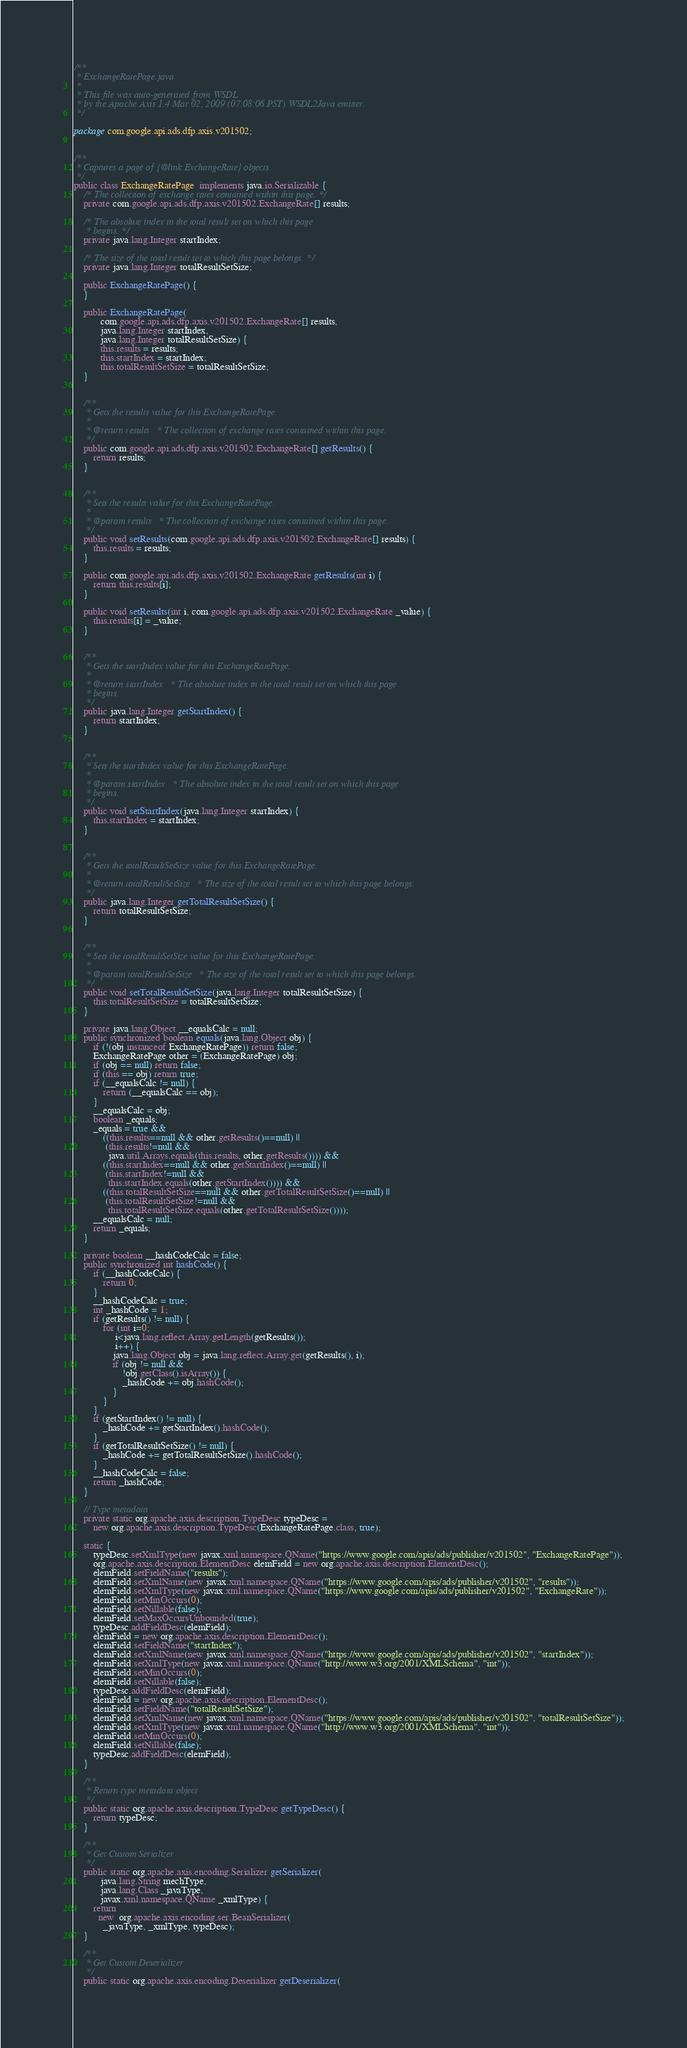Convert code to text. <code><loc_0><loc_0><loc_500><loc_500><_Java_>/**
 * ExchangeRatePage.java
 *
 * This file was auto-generated from WSDL
 * by the Apache Axis 1.4 Mar 02, 2009 (07:08:06 PST) WSDL2Java emitter.
 */

package com.google.api.ads.dfp.axis.v201502;


/**
 * Captures a page of {@link ExchangeRate} objects.
 */
public class ExchangeRatePage  implements java.io.Serializable {
    /* The collection of exchange rates contained within this page. */
    private com.google.api.ads.dfp.axis.v201502.ExchangeRate[] results;

    /* The absolute index in the total result set on which this page
     * begins. */
    private java.lang.Integer startIndex;

    /* The size of the total result set to which this page belongs. */
    private java.lang.Integer totalResultSetSize;

    public ExchangeRatePage() {
    }

    public ExchangeRatePage(
           com.google.api.ads.dfp.axis.v201502.ExchangeRate[] results,
           java.lang.Integer startIndex,
           java.lang.Integer totalResultSetSize) {
           this.results = results;
           this.startIndex = startIndex;
           this.totalResultSetSize = totalResultSetSize;
    }


    /**
     * Gets the results value for this ExchangeRatePage.
     * 
     * @return results   * The collection of exchange rates contained within this page.
     */
    public com.google.api.ads.dfp.axis.v201502.ExchangeRate[] getResults() {
        return results;
    }


    /**
     * Sets the results value for this ExchangeRatePage.
     * 
     * @param results   * The collection of exchange rates contained within this page.
     */
    public void setResults(com.google.api.ads.dfp.axis.v201502.ExchangeRate[] results) {
        this.results = results;
    }

    public com.google.api.ads.dfp.axis.v201502.ExchangeRate getResults(int i) {
        return this.results[i];
    }

    public void setResults(int i, com.google.api.ads.dfp.axis.v201502.ExchangeRate _value) {
        this.results[i] = _value;
    }


    /**
     * Gets the startIndex value for this ExchangeRatePage.
     * 
     * @return startIndex   * The absolute index in the total result set on which this page
     * begins.
     */
    public java.lang.Integer getStartIndex() {
        return startIndex;
    }


    /**
     * Sets the startIndex value for this ExchangeRatePage.
     * 
     * @param startIndex   * The absolute index in the total result set on which this page
     * begins.
     */
    public void setStartIndex(java.lang.Integer startIndex) {
        this.startIndex = startIndex;
    }


    /**
     * Gets the totalResultSetSize value for this ExchangeRatePage.
     * 
     * @return totalResultSetSize   * The size of the total result set to which this page belongs.
     */
    public java.lang.Integer getTotalResultSetSize() {
        return totalResultSetSize;
    }


    /**
     * Sets the totalResultSetSize value for this ExchangeRatePage.
     * 
     * @param totalResultSetSize   * The size of the total result set to which this page belongs.
     */
    public void setTotalResultSetSize(java.lang.Integer totalResultSetSize) {
        this.totalResultSetSize = totalResultSetSize;
    }

    private java.lang.Object __equalsCalc = null;
    public synchronized boolean equals(java.lang.Object obj) {
        if (!(obj instanceof ExchangeRatePage)) return false;
        ExchangeRatePage other = (ExchangeRatePage) obj;
        if (obj == null) return false;
        if (this == obj) return true;
        if (__equalsCalc != null) {
            return (__equalsCalc == obj);
        }
        __equalsCalc = obj;
        boolean _equals;
        _equals = true && 
            ((this.results==null && other.getResults()==null) || 
             (this.results!=null &&
              java.util.Arrays.equals(this.results, other.getResults()))) &&
            ((this.startIndex==null && other.getStartIndex()==null) || 
             (this.startIndex!=null &&
              this.startIndex.equals(other.getStartIndex()))) &&
            ((this.totalResultSetSize==null && other.getTotalResultSetSize()==null) || 
             (this.totalResultSetSize!=null &&
              this.totalResultSetSize.equals(other.getTotalResultSetSize())));
        __equalsCalc = null;
        return _equals;
    }

    private boolean __hashCodeCalc = false;
    public synchronized int hashCode() {
        if (__hashCodeCalc) {
            return 0;
        }
        __hashCodeCalc = true;
        int _hashCode = 1;
        if (getResults() != null) {
            for (int i=0;
                 i<java.lang.reflect.Array.getLength(getResults());
                 i++) {
                java.lang.Object obj = java.lang.reflect.Array.get(getResults(), i);
                if (obj != null &&
                    !obj.getClass().isArray()) {
                    _hashCode += obj.hashCode();
                }
            }
        }
        if (getStartIndex() != null) {
            _hashCode += getStartIndex().hashCode();
        }
        if (getTotalResultSetSize() != null) {
            _hashCode += getTotalResultSetSize().hashCode();
        }
        __hashCodeCalc = false;
        return _hashCode;
    }

    // Type metadata
    private static org.apache.axis.description.TypeDesc typeDesc =
        new org.apache.axis.description.TypeDesc(ExchangeRatePage.class, true);

    static {
        typeDesc.setXmlType(new javax.xml.namespace.QName("https://www.google.com/apis/ads/publisher/v201502", "ExchangeRatePage"));
        org.apache.axis.description.ElementDesc elemField = new org.apache.axis.description.ElementDesc();
        elemField.setFieldName("results");
        elemField.setXmlName(new javax.xml.namespace.QName("https://www.google.com/apis/ads/publisher/v201502", "results"));
        elemField.setXmlType(new javax.xml.namespace.QName("https://www.google.com/apis/ads/publisher/v201502", "ExchangeRate"));
        elemField.setMinOccurs(0);
        elemField.setNillable(false);
        elemField.setMaxOccursUnbounded(true);
        typeDesc.addFieldDesc(elemField);
        elemField = new org.apache.axis.description.ElementDesc();
        elemField.setFieldName("startIndex");
        elemField.setXmlName(new javax.xml.namespace.QName("https://www.google.com/apis/ads/publisher/v201502", "startIndex"));
        elemField.setXmlType(new javax.xml.namespace.QName("http://www.w3.org/2001/XMLSchema", "int"));
        elemField.setMinOccurs(0);
        elemField.setNillable(false);
        typeDesc.addFieldDesc(elemField);
        elemField = new org.apache.axis.description.ElementDesc();
        elemField.setFieldName("totalResultSetSize");
        elemField.setXmlName(new javax.xml.namespace.QName("https://www.google.com/apis/ads/publisher/v201502", "totalResultSetSize"));
        elemField.setXmlType(new javax.xml.namespace.QName("http://www.w3.org/2001/XMLSchema", "int"));
        elemField.setMinOccurs(0);
        elemField.setNillable(false);
        typeDesc.addFieldDesc(elemField);
    }

    /**
     * Return type metadata object
     */
    public static org.apache.axis.description.TypeDesc getTypeDesc() {
        return typeDesc;
    }

    /**
     * Get Custom Serializer
     */
    public static org.apache.axis.encoding.Serializer getSerializer(
           java.lang.String mechType, 
           java.lang.Class _javaType,  
           javax.xml.namespace.QName _xmlType) {
        return 
          new  org.apache.axis.encoding.ser.BeanSerializer(
            _javaType, _xmlType, typeDesc);
    }

    /**
     * Get Custom Deserializer
     */
    public static org.apache.axis.encoding.Deserializer getDeserializer(</code> 